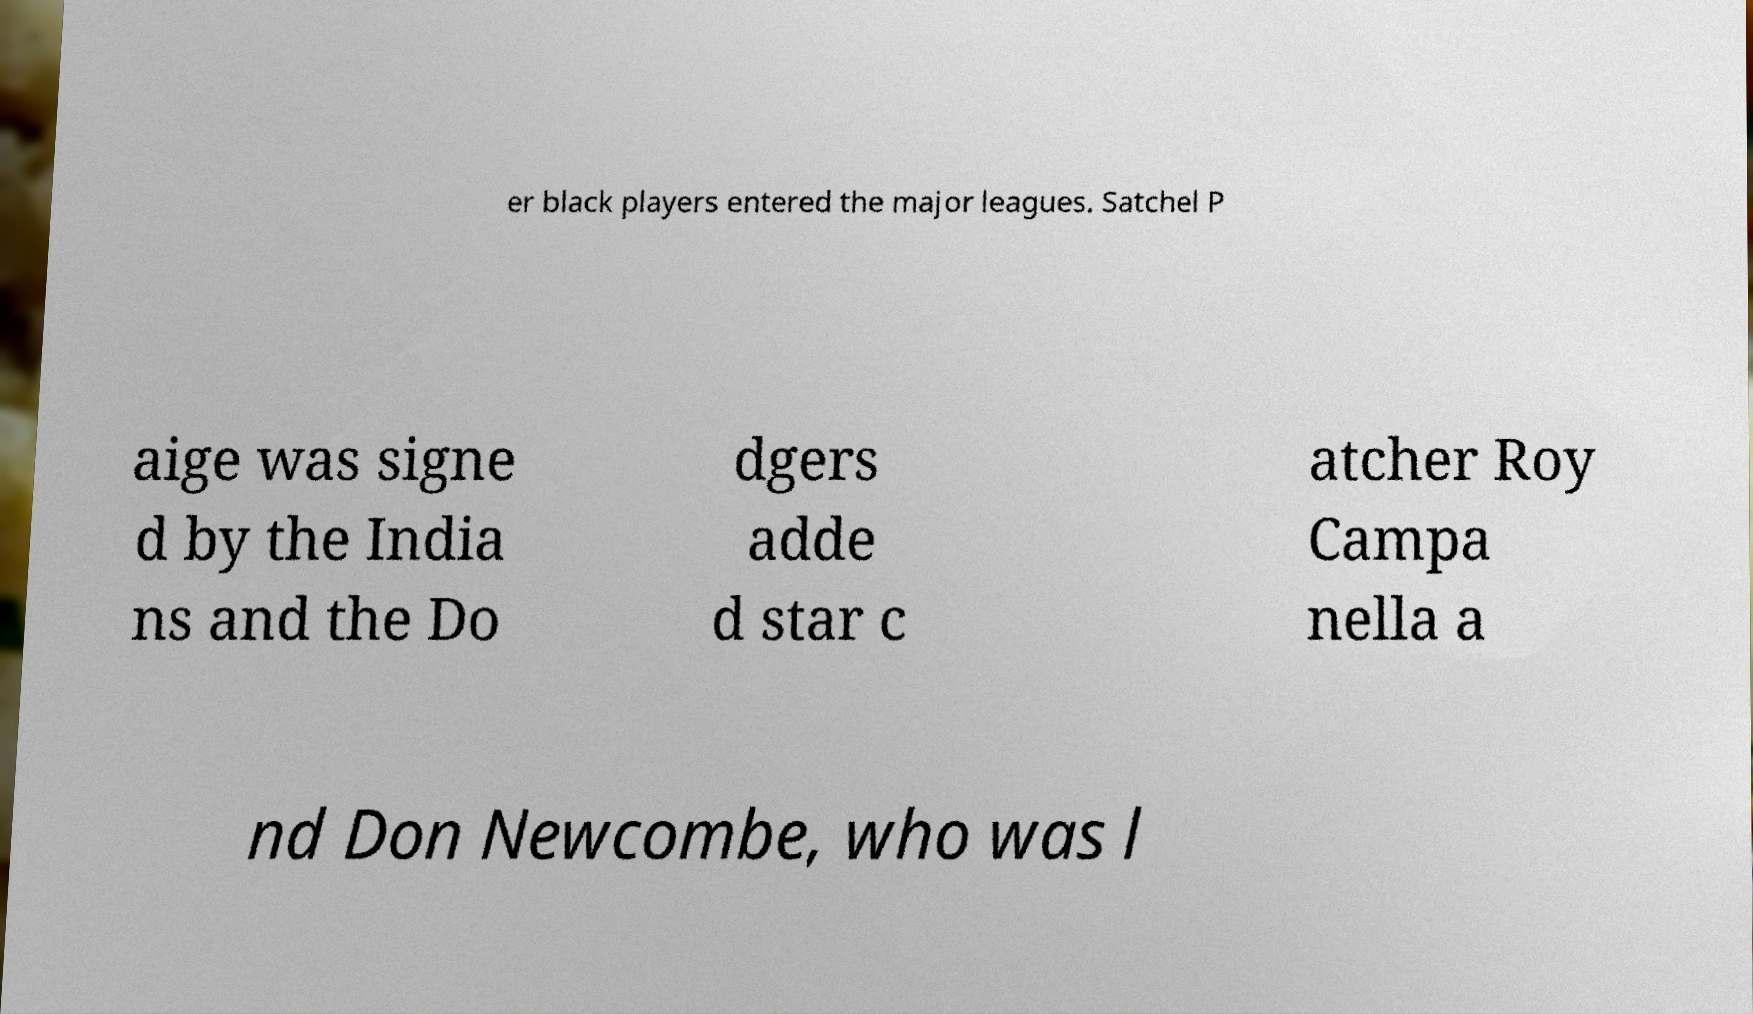I need the written content from this picture converted into text. Can you do that? er black players entered the major leagues. Satchel P aige was signe d by the India ns and the Do dgers adde d star c atcher Roy Campa nella a nd Don Newcombe, who was l 